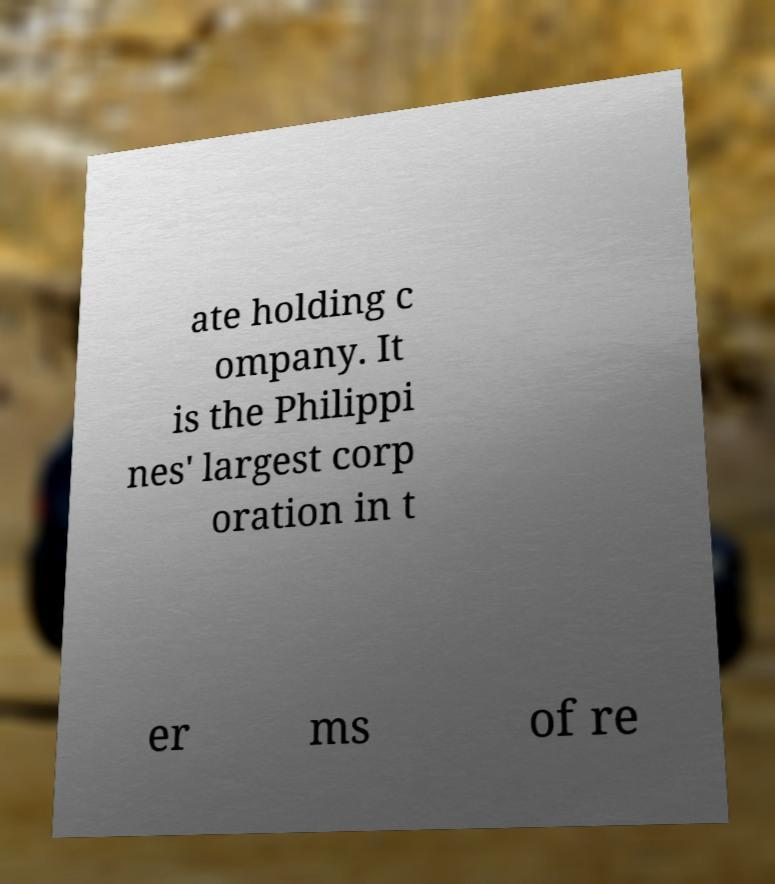Please identify and transcribe the text found in this image. ate holding c ompany. It is the Philippi nes' largest corp oration in t er ms of re 